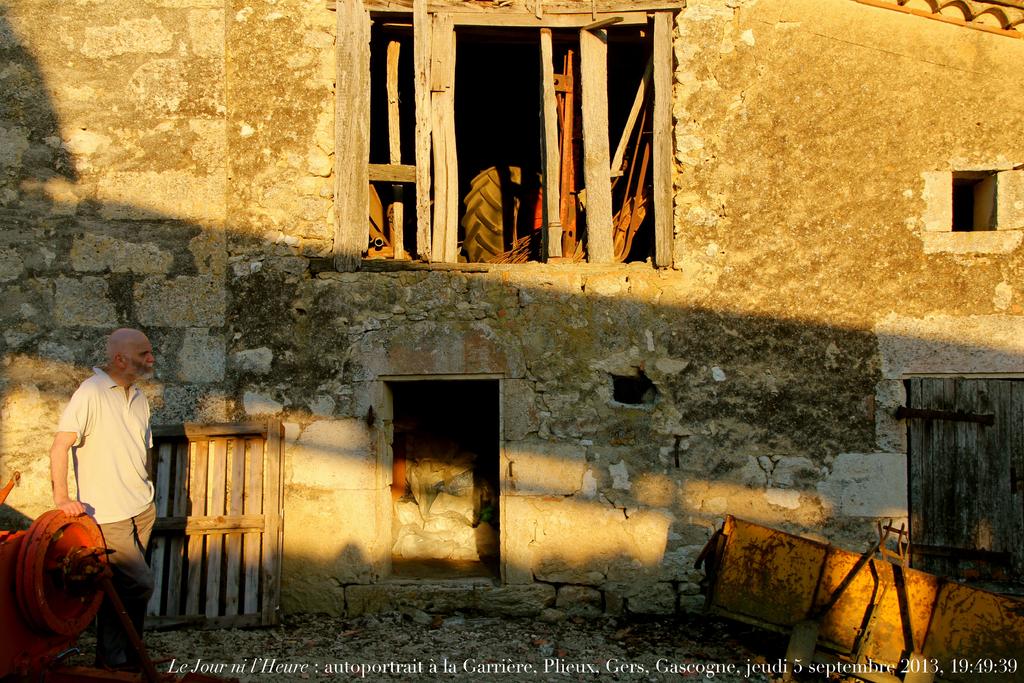What year was this taken?
Provide a succinct answer. 2013. 